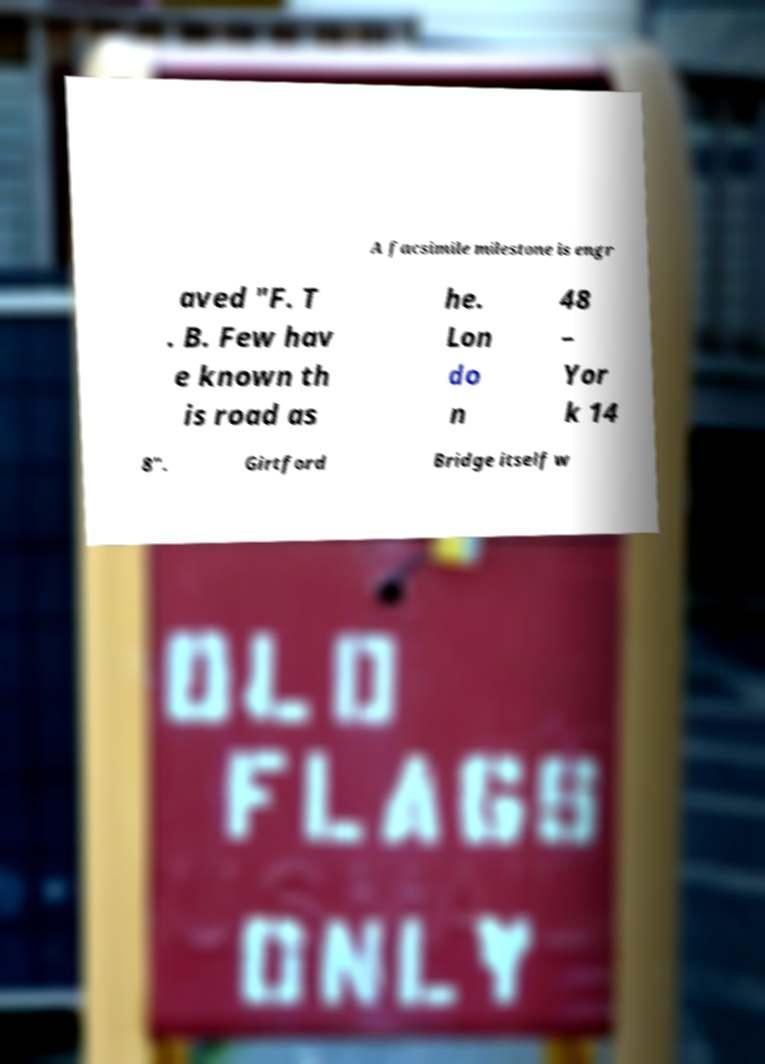I need the written content from this picture converted into text. Can you do that? A facsimile milestone is engr aved "F. T . B. Few hav e known th is road as he. Lon do n 48 – Yor k 14 8". Girtford Bridge itself w 